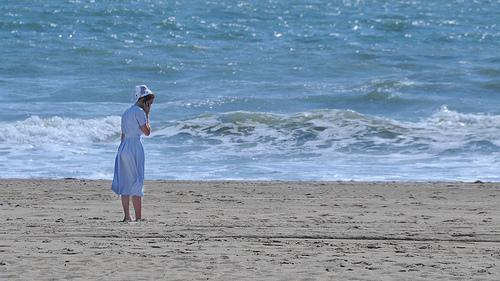How many ocean wave sections are mentioned in the image? There are 19 sections of blue and white ocean waves mentioned. Using complex reasoning, provide a possible reason why the woman is talking on the phone at the beach. The woman might be talking on the phone to share her beach experience with a friend or family member, or attending to an important matter while enjoying her time at the beach. What color is the dress the woman is wearing, and what is she doing with her right hand? The woman is wearing a white dress and holding a phone with her right hand. Explain the interaction between the woman and the environment in the image. The woman is standing on the sandy beach, talking on the phone, with her feet in the sand, and waves crashing onto the shore nearby. What type of clothing is the woman on the beach wearing? The woman is wearing a dress and a hat on the beach. Count the number of water-related objects and describe their main characteristic. There are 19 water-related objects, which are blue and white ocean waves. Evaluate the quality of the image by mentioning the key elements. The image quality is good, with clear and distinct elements including the woman in a dress, the sandy beach, and blue and white ocean waves. Analyze the mood or sentiment portrayed in the image. The image portrays a peaceful and relaxing sentiment with the woman standing on the beach near the ocean waves. How many different descriptions of the woman on the beach are there in the image? There are 14 different descriptions of the woman on the beach. Provide a brief description of the woman's appearance and actions in the image. The woman is wearing a white dress, a hat, and talking on the phone while standing on the sand at the beach. Can you see a group of dolphins gracefully swimming and jumping in the waves? They must be having a great time! No, it's not mentioned in the image. 